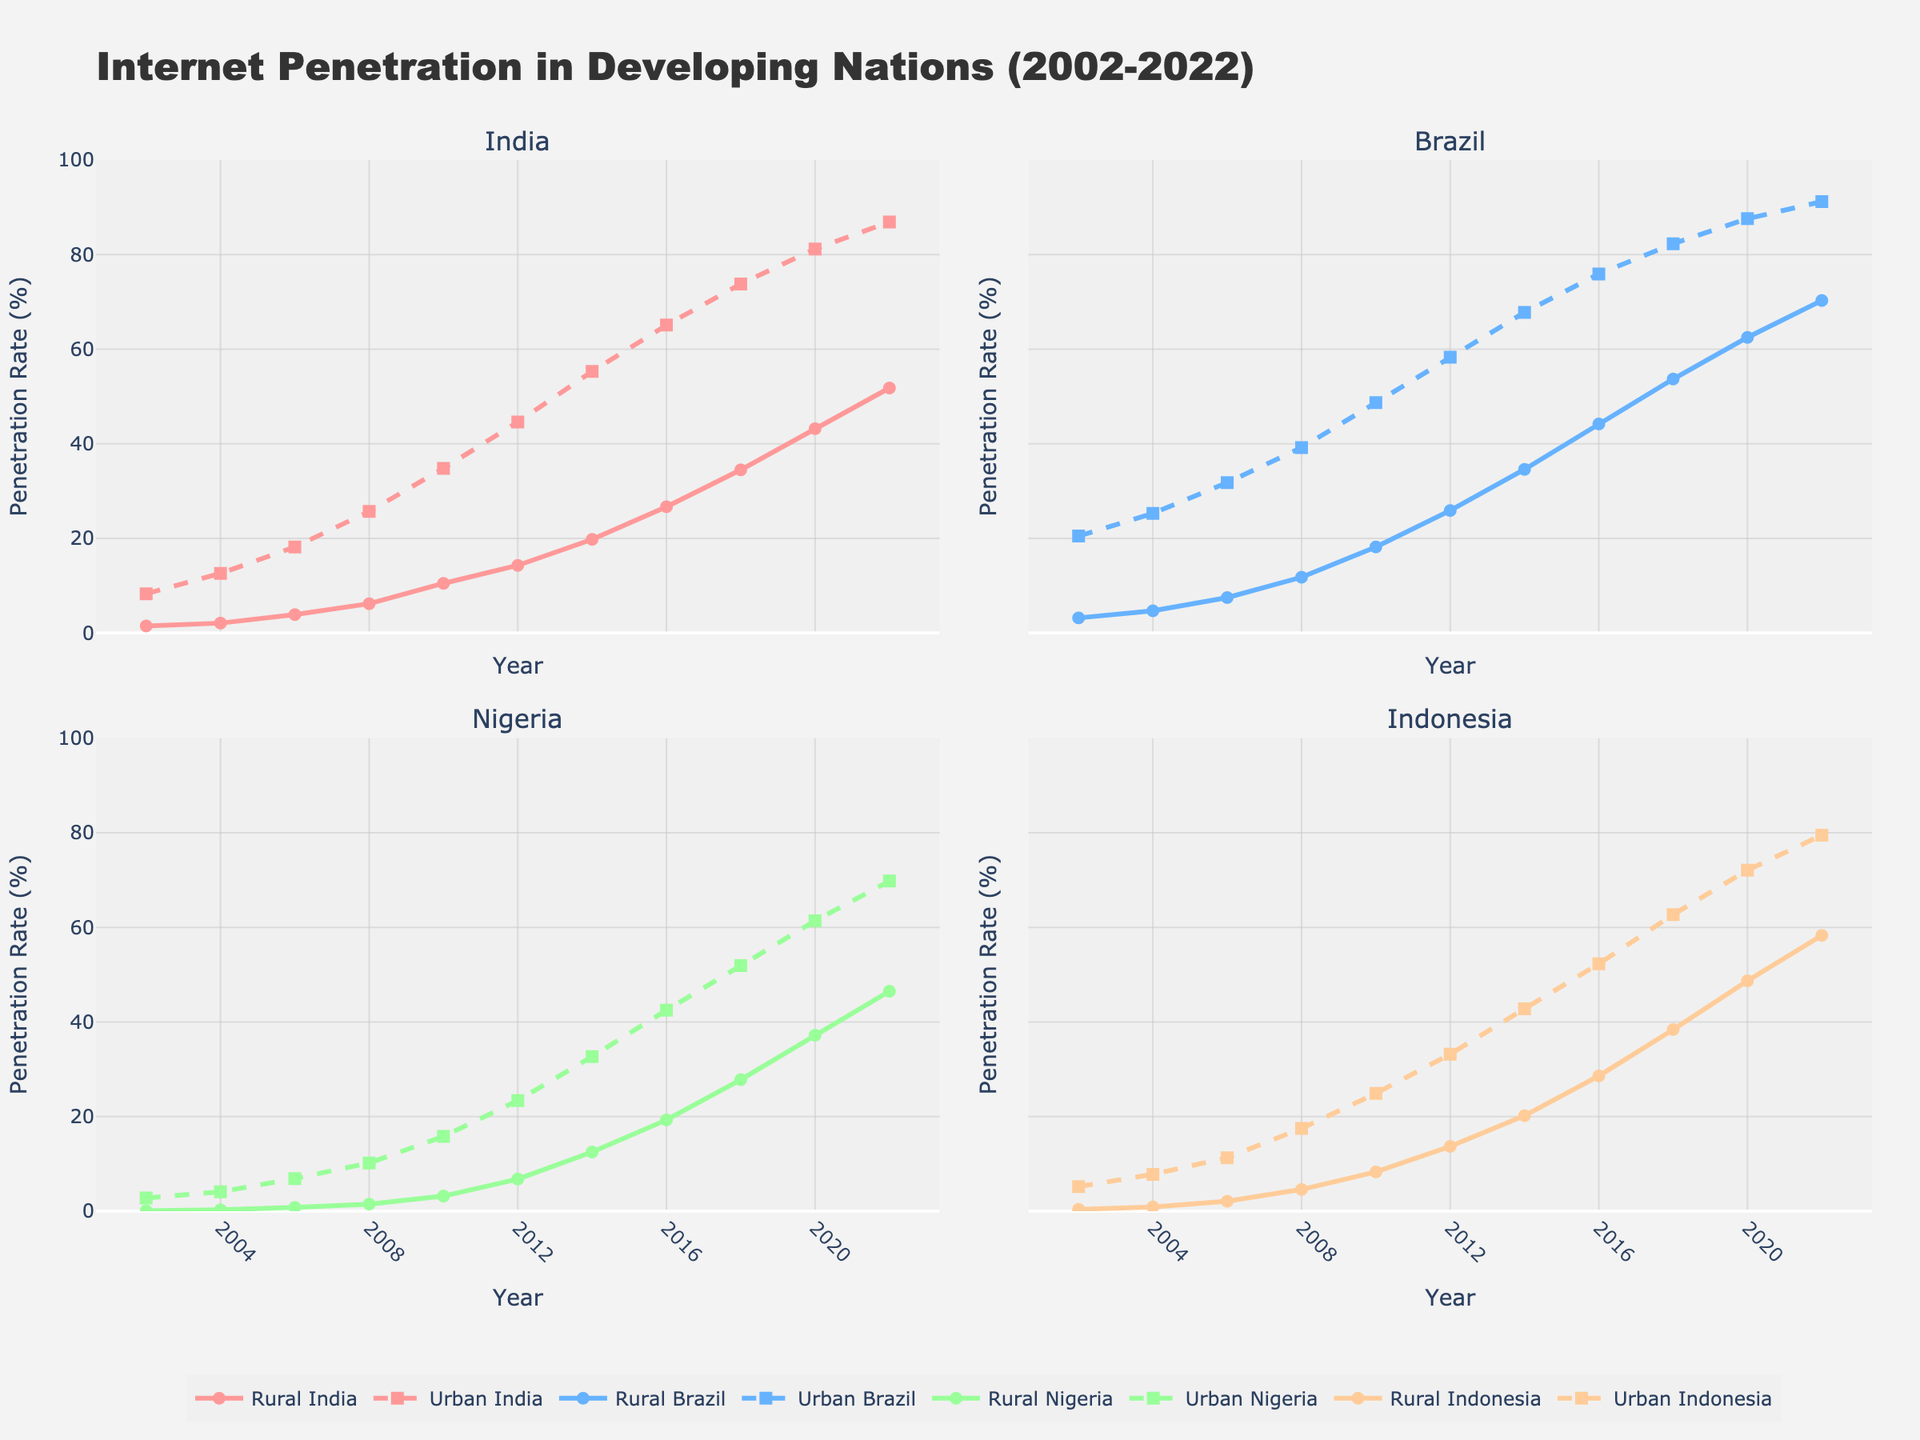What is the difference in internet penetration rates between urban and rural India in 2022? First, locate the penetration rates for urban and rural India in 2022 from the figure. Urban India's rate is 86.9%, and rural India's rate is 51.8%. Subtract the rural rate from the urban rate: 86.9% - 51.8% = 35.1%.
Answer: 35.1% Which country shows the greatest increase in rural internet penetration from 2002 to 2022? Check the starting values in 2002 and the ending values in 2022 for rural penetration in all four countries. India increases from 1.5% to 51.8% (+50.3), Brazil from 3.2% to 70.3% (+67.1), Nigeria from 0.1% to 46.5% (+46.4), and Indonesia from 0.4% to 58.3% (+57.9). Brazil has the highest increase.
Answer: Brazil In 2010, did any rural area surpass the 10% internet penetration rate? Look at the 2010 values for each rural area. Rural India is at 10.5%, rural Brazil is at 18.2%, rural Nigeria is at 3.2%, and rural Indonesia is at 8.3%. Only rural India and rural Brazil surpass the 10% mark.
Answer: Yes, rural India and rural Brazil Compare the growth trends of urban Nigeria and urban Indonesia from 2002 to 2022. Which has a steeper trend? Look at the slopes of the lines for urban Nigeria and urban Indonesia. Both lines increase, but urban Nigeria starts at 2.8% in 2002 and ends at 69.8% in 2022 (+67.0), while urban Indonesia starts at 5.2% and ends at 79.5% (+74.3). Hence, urban Indonesia has a steeper trend.
Answer: Urban Indonesia By how much did rural Nigeria's internet penetration increase between 2008 and 2018? Note rural Nigeria's penetration rate in 2008 (1.5%) and in 2018 (27.8%). Subtract the 2008 value from the 2018 value: 27.8% - 1.5% = 26.3%.
Answer: 26.3% Identify the year when urban penetration rates in all countries exceeded 50%. Observe the graphs for each urban area and note the year when all lines cross the 50% threshold. In 2010, urban India, urban Brazil, urban Nigeria, and urban Indonesia all exceed or are close to exceeding 50%.
Answer: 2010 How does the internet penetration rate in rural areas of Indonesia in 2020 compare to urban areas in India in 2008? Find rural Indonesia's rate in 2020 (48.7%) and urban India's rate in 2008 (25.7%). Compare these two values numerically to see if one is higher or lower.
Answer: Rural Indonesia is higher What is the average internet penetration rate across rural areas in all four countries in 2012? Add the 2012 rural rates for India (14.3%), Brazil (25.9%), Nigeria (6.8%), and Indonesia (13.7%), then divide by 4. The calculation is (14.3 + 25.9 + 6.8 + 13.7) / 4 = 60.7 / 4 = 15.175%.
Answer: 15.175% Which country's urban area had the smallest increase in internet penetration from 2006 to 2022? Examine the increase for urban areas in each country: India (from 18.2% to 86.9%, +68.7), Brazil (from 31.8% to 91.2%, +59.4), Nigeria (from 6.9% to 69.8%, +62.9), and Indonesia (from 11.3% to 79.5%, +68.2). Brazil has the smallest increase.
Answer: Brazil 